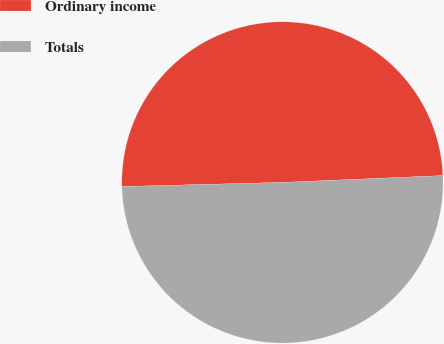Convert chart to OTSL. <chart><loc_0><loc_0><loc_500><loc_500><pie_chart><fcel>Ordinary income<fcel>Totals<nl><fcel>49.73%<fcel>50.27%<nl></chart> 